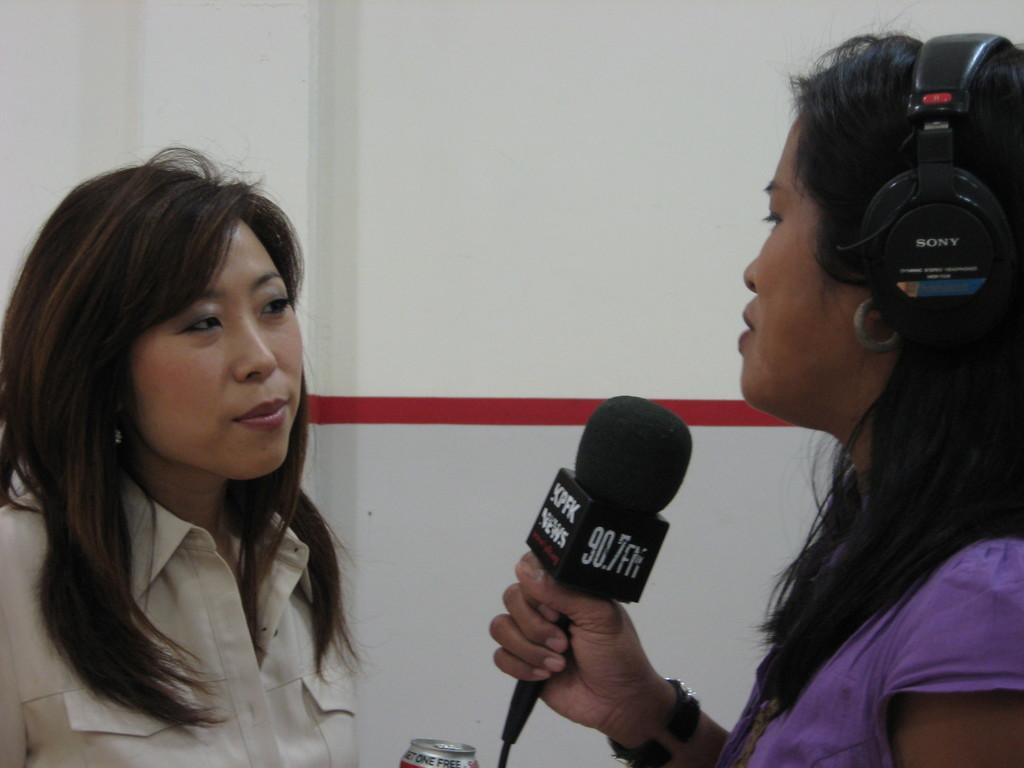What can be observed about the people in the image? There are women standing in the image. What is one of the women holding in her hand? One woman is holding a mic in her hand. What accessory is the woman with the mic wearing? The woman with the mic is wearing headphones. What type of fork is the woman using to eat her meal in the image? There is no fork or meal present in the image; the woman is holding a mic and wearing headphones. 